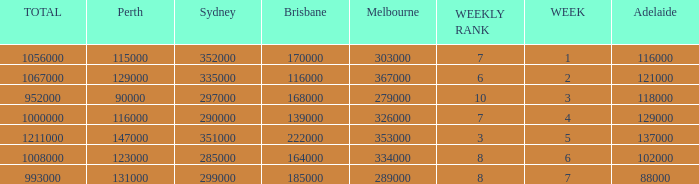Could you parse the entire table? {'header': ['TOTAL', 'Perth', 'Sydney', 'Brisbane', 'Melbourne', 'WEEKLY RANK', 'WEEK', 'Adelaide'], 'rows': [['1056000', '115000', '352000', '170000', '303000', '7', '1', '116000'], ['1067000', '129000', '335000', '116000', '367000', '6', '2', '121000'], ['952000', '90000', '297000', '168000', '279000', '10', '3', '118000'], ['1000000', '116000', '290000', '139000', '326000', '7', '4', '129000'], ['1211000', '147000', '351000', '222000', '353000', '3', '5', '137000'], ['1008000', '123000', '285000', '164000', '334000', '8', '6', '102000'], ['993000', '131000', '299000', '185000', '289000', '8', '7', '88000']]} What is the highest number of Brisbane viewers? 222000.0. 